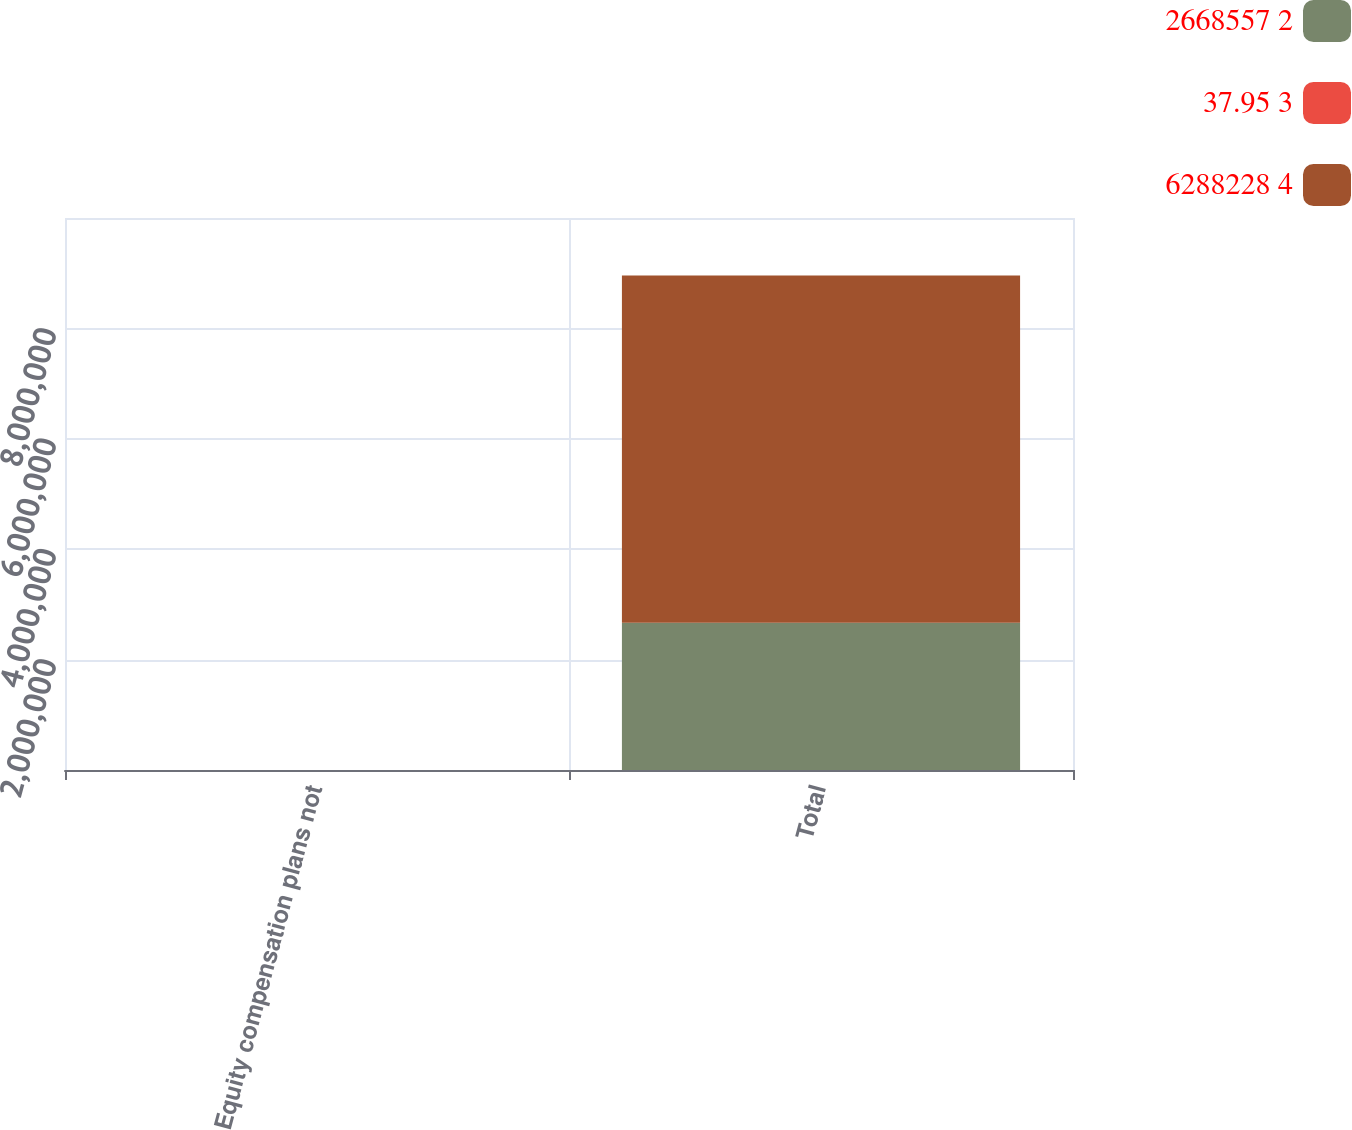<chart> <loc_0><loc_0><loc_500><loc_500><stacked_bar_chart><ecel><fcel>Equity compensation plans not<fcel>Total<nl><fcel>2668557 2<fcel>0<fcel>2.66856e+06<nl><fcel>37.95 3<fcel>0<fcel>37.95<nl><fcel>6288228 4<fcel>0<fcel>6.28823e+06<nl></chart> 